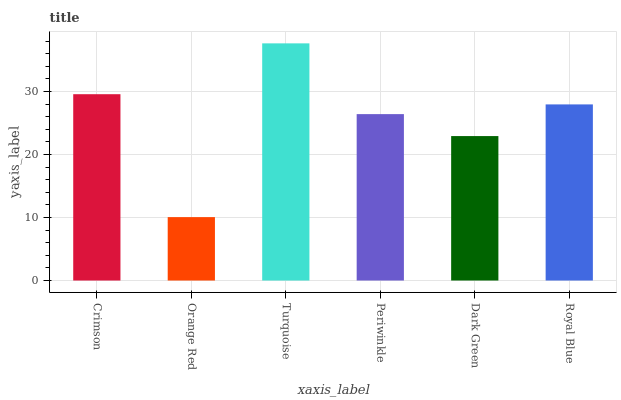Is Orange Red the minimum?
Answer yes or no. Yes. Is Turquoise the maximum?
Answer yes or no. Yes. Is Turquoise the minimum?
Answer yes or no. No. Is Orange Red the maximum?
Answer yes or no. No. Is Turquoise greater than Orange Red?
Answer yes or no. Yes. Is Orange Red less than Turquoise?
Answer yes or no. Yes. Is Orange Red greater than Turquoise?
Answer yes or no. No. Is Turquoise less than Orange Red?
Answer yes or no. No. Is Royal Blue the high median?
Answer yes or no. Yes. Is Periwinkle the low median?
Answer yes or no. Yes. Is Crimson the high median?
Answer yes or no. No. Is Dark Green the low median?
Answer yes or no. No. 